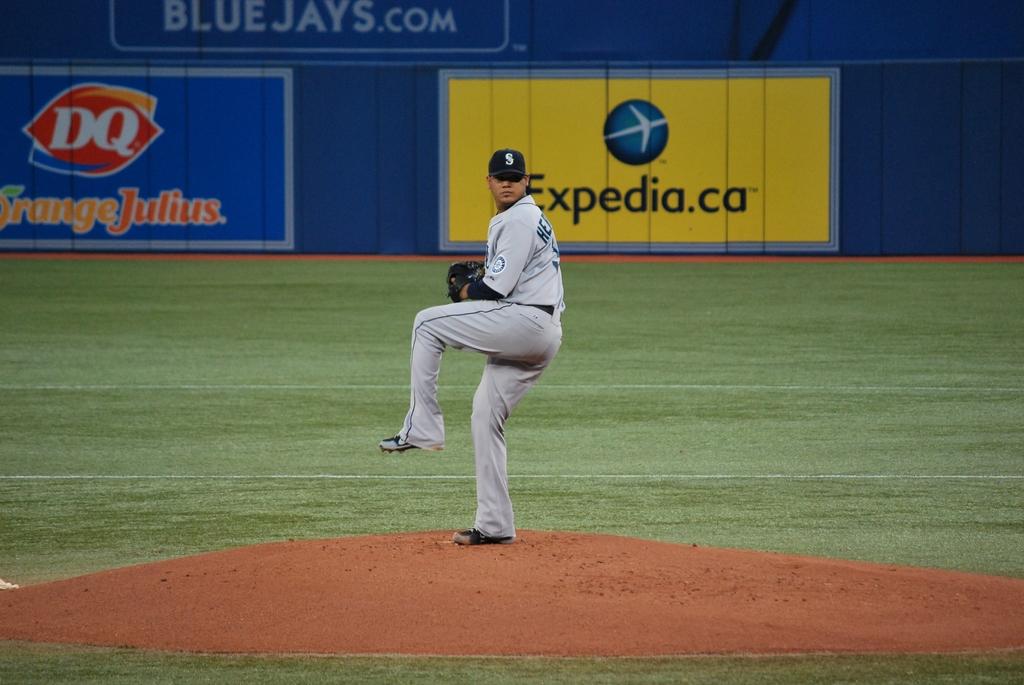What is the website on the yellow billboard?
Offer a terse response. Expedia.ca. 